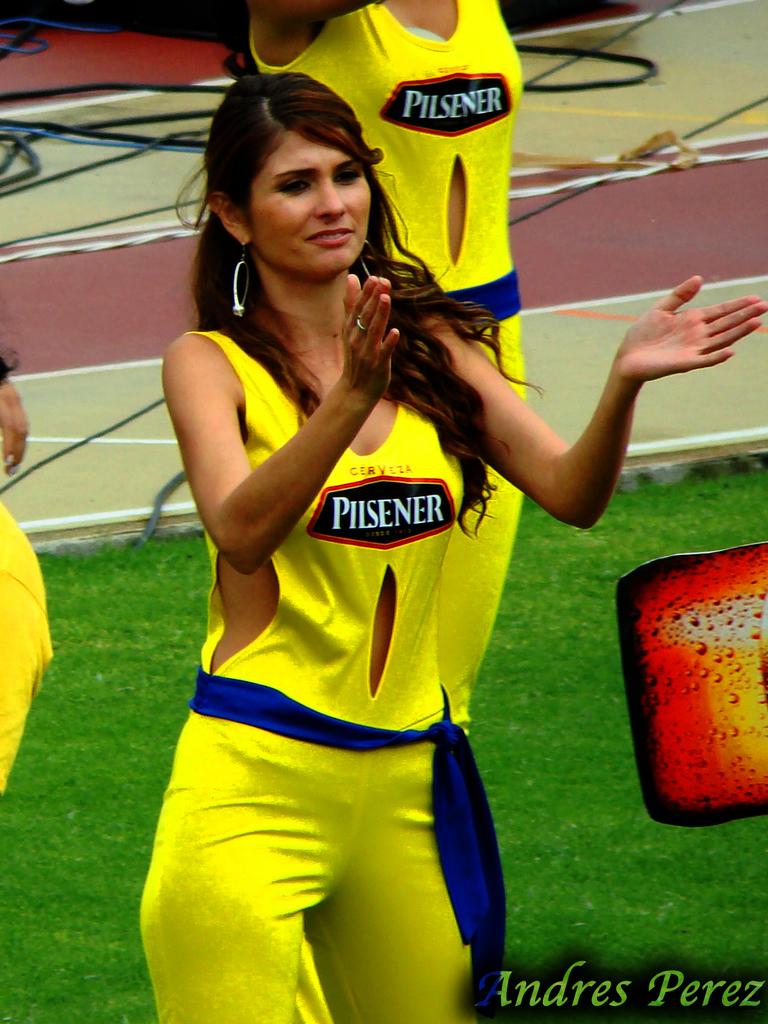What is the sponsor on the front of their shirt?
Offer a very short reply. Pilsener. Is pilsener a brand of beer?
Your response must be concise. Yes. 